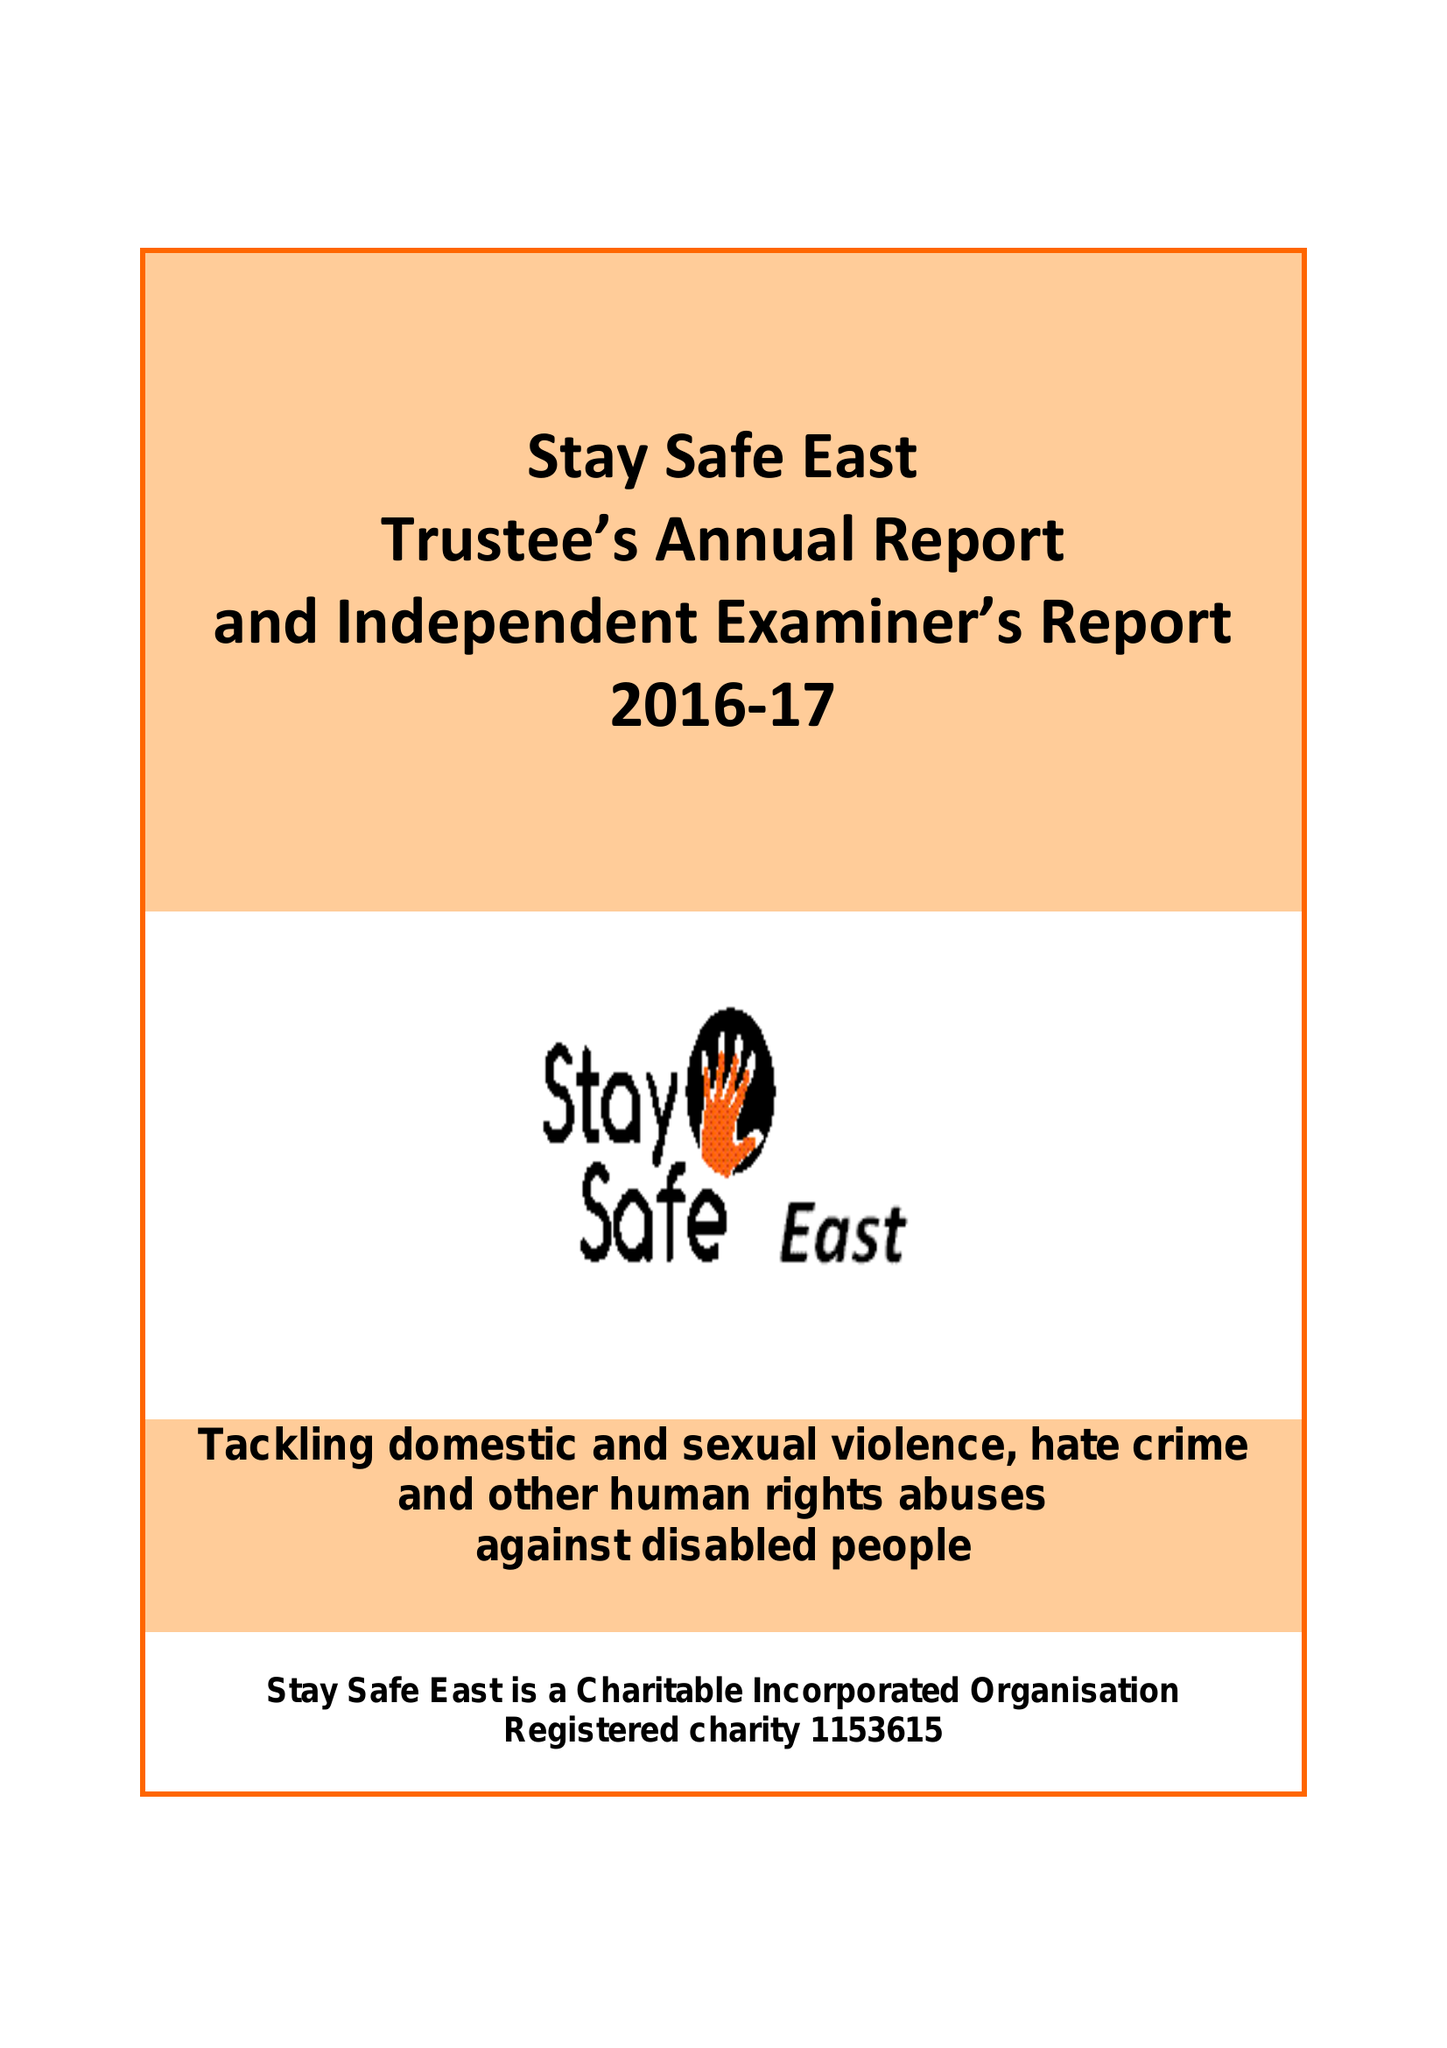What is the value for the charity_number?
Answer the question using a single word or phrase. 1153615 